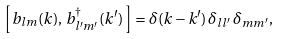Convert formula to latex. <formula><loc_0><loc_0><loc_500><loc_500>\left [ \, b _ { l m } ( k ) , \, b _ { l ^ { \prime } m ^ { \prime } } ^ { \dagger } ( k ^ { \prime } ) \, \right ] = \delta ( k - k ^ { \prime } ) \, \delta _ { l l ^ { \prime } } \, \delta _ { m m ^ { \prime } } ,</formula> 